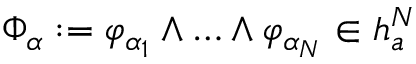Convert formula to latex. <formula><loc_0><loc_0><loc_500><loc_500>\Phi _ { \alpha } \colon = \varphi _ { \alpha _ { 1 } } \wedge \dots \wedge \varphi _ { \alpha _ { N } } \in \mathfrak { h } _ { a } ^ { N }</formula> 